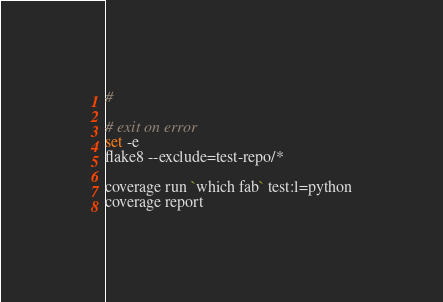Convert code to text. <code><loc_0><loc_0><loc_500><loc_500><_Bash_>#

# exit on error
set -e
flake8 --exclude=test-repo/*

coverage run `which fab` test:l=python
coverage report
</code> 